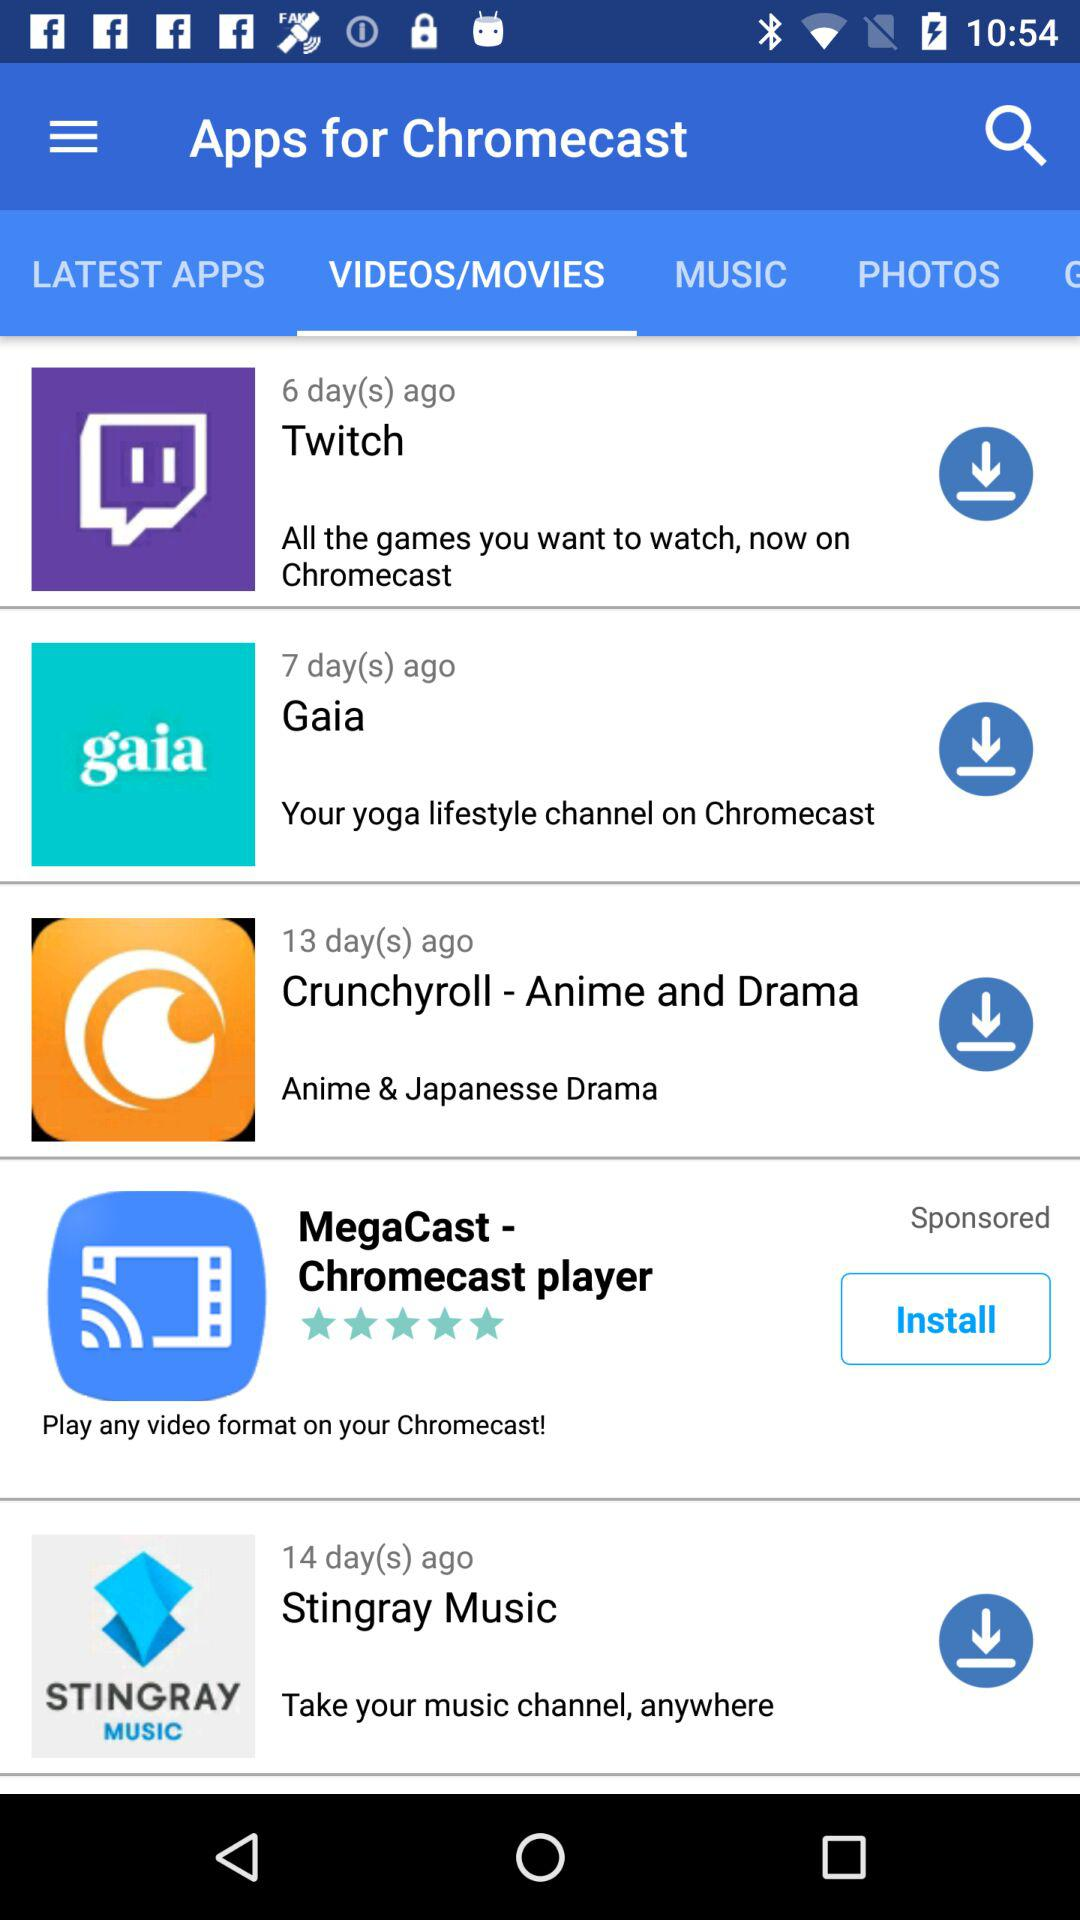How many apps are sponsored?
Answer the question using a single word or phrase. 1 